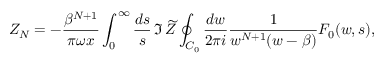<formula> <loc_0><loc_0><loc_500><loc_500>Z _ { N } = - { \frac { \beta ^ { N + 1 } } { \pi \omega x } } \int _ { 0 } ^ { \infty } { \frac { d s } { s } } \, \Im \, \widetilde { Z } \oint _ { C _ { 0 } } { \frac { d w } { 2 \pi i } } { \frac { 1 } { w ^ { N + 1 } ( w - \beta ) } } F _ { 0 } ( w , s ) ,</formula> 